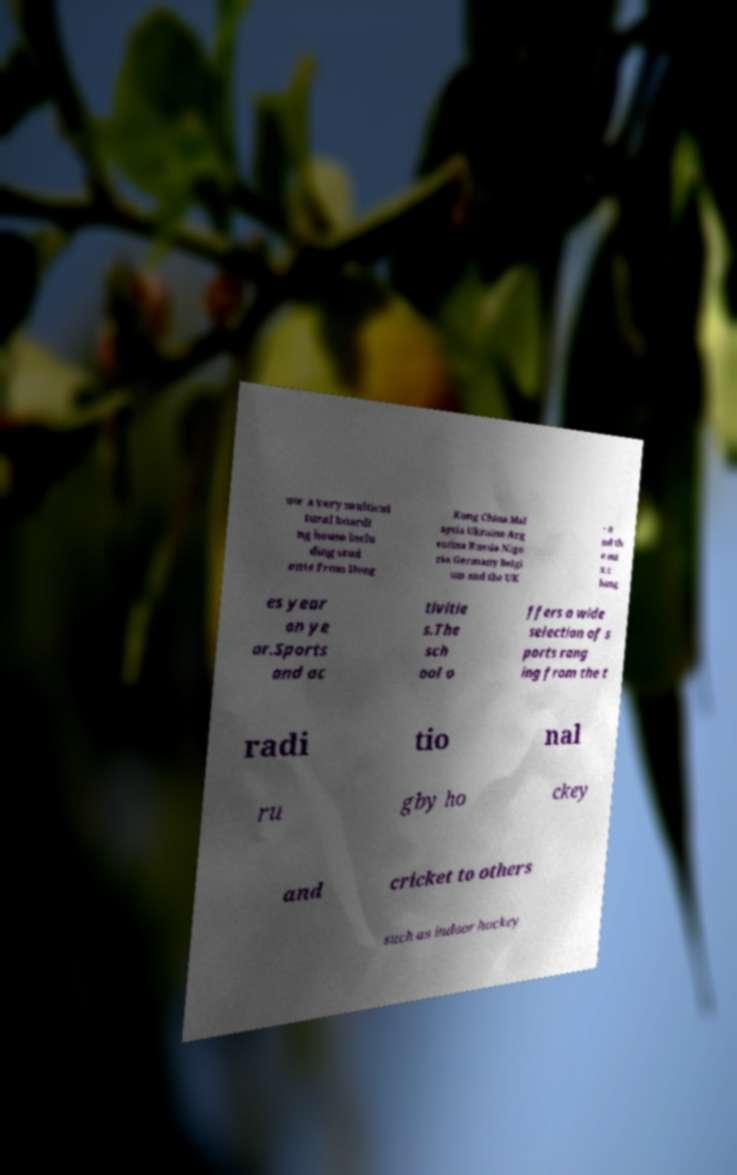Please read and relay the text visible in this image. What does it say? ow a very multicul tural boardi ng house inclu ding stud ents from Hong Kong China Mal aysia Ukraine Arg entina Russia Nige ria Germany Belgi um and the UK - a nd th e mi x c hang es year on ye ar.Sports and ac tivitie s.The sch ool o ffers a wide selection of s ports rang ing from the t radi tio nal ru gby ho ckey and cricket to others such as indoor hockey 